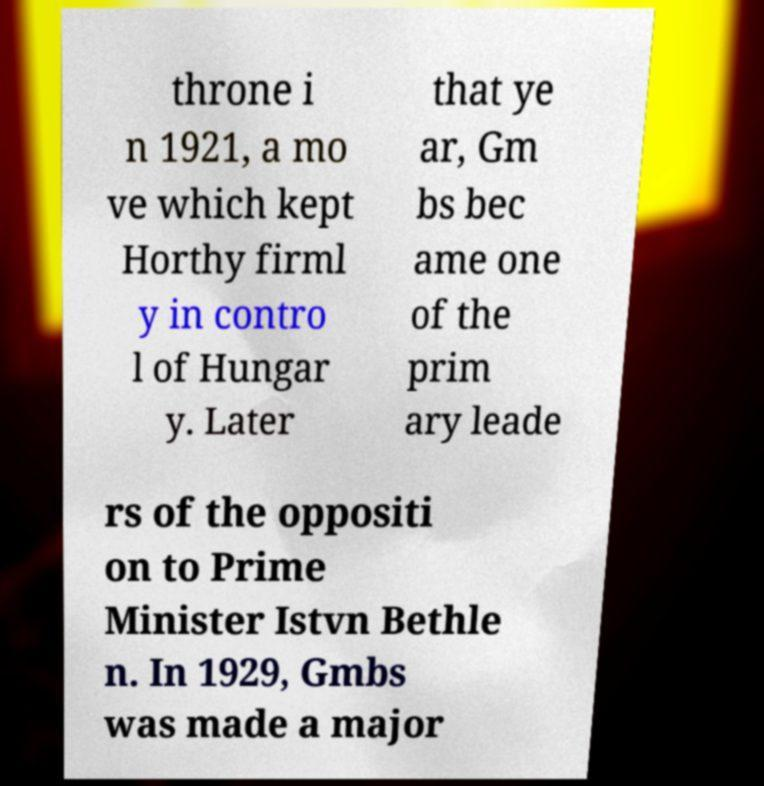I need the written content from this picture converted into text. Can you do that? throne i n 1921, a mo ve which kept Horthy firml y in contro l of Hungar y. Later that ye ar, Gm bs bec ame one of the prim ary leade rs of the oppositi on to Prime Minister Istvn Bethle n. In 1929, Gmbs was made a major 